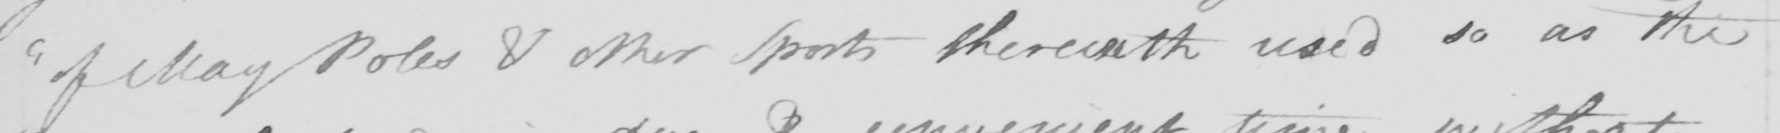Can you read and transcribe this handwriting? " of May Poles & other Sports therewith used so as the 